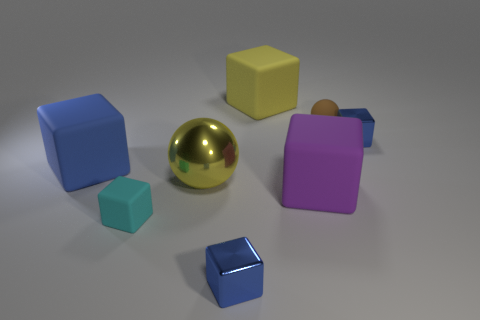Is there a green sphere that has the same material as the purple thing?
Keep it short and to the point. No. How many yellow things are matte cubes or large rubber cubes?
Your response must be concise. 1. There is a rubber block that is both behind the big purple block and in front of the big yellow block; how big is it?
Your answer should be very brief. Large. Is the number of rubber cubes that are behind the yellow sphere greater than the number of small blue cubes?
Provide a succinct answer. No. How many balls are either yellow things or blue rubber objects?
Provide a succinct answer. 1. There is a matte thing that is behind the small cyan rubber cube and on the left side of the yellow matte block; what shape is it?
Ensure brevity in your answer.  Cube. Are there the same number of small matte cubes right of the big purple rubber cube and big blocks that are in front of the blue rubber cube?
Ensure brevity in your answer.  No. How many things are either big balls or yellow matte cylinders?
Give a very brief answer. 1. What color is the ball that is the same size as the yellow rubber object?
Give a very brief answer. Yellow. What number of things are either tiny blue metallic things that are in front of the big blue object or small cubes that are on the left side of the tiny sphere?
Provide a succinct answer. 2. 